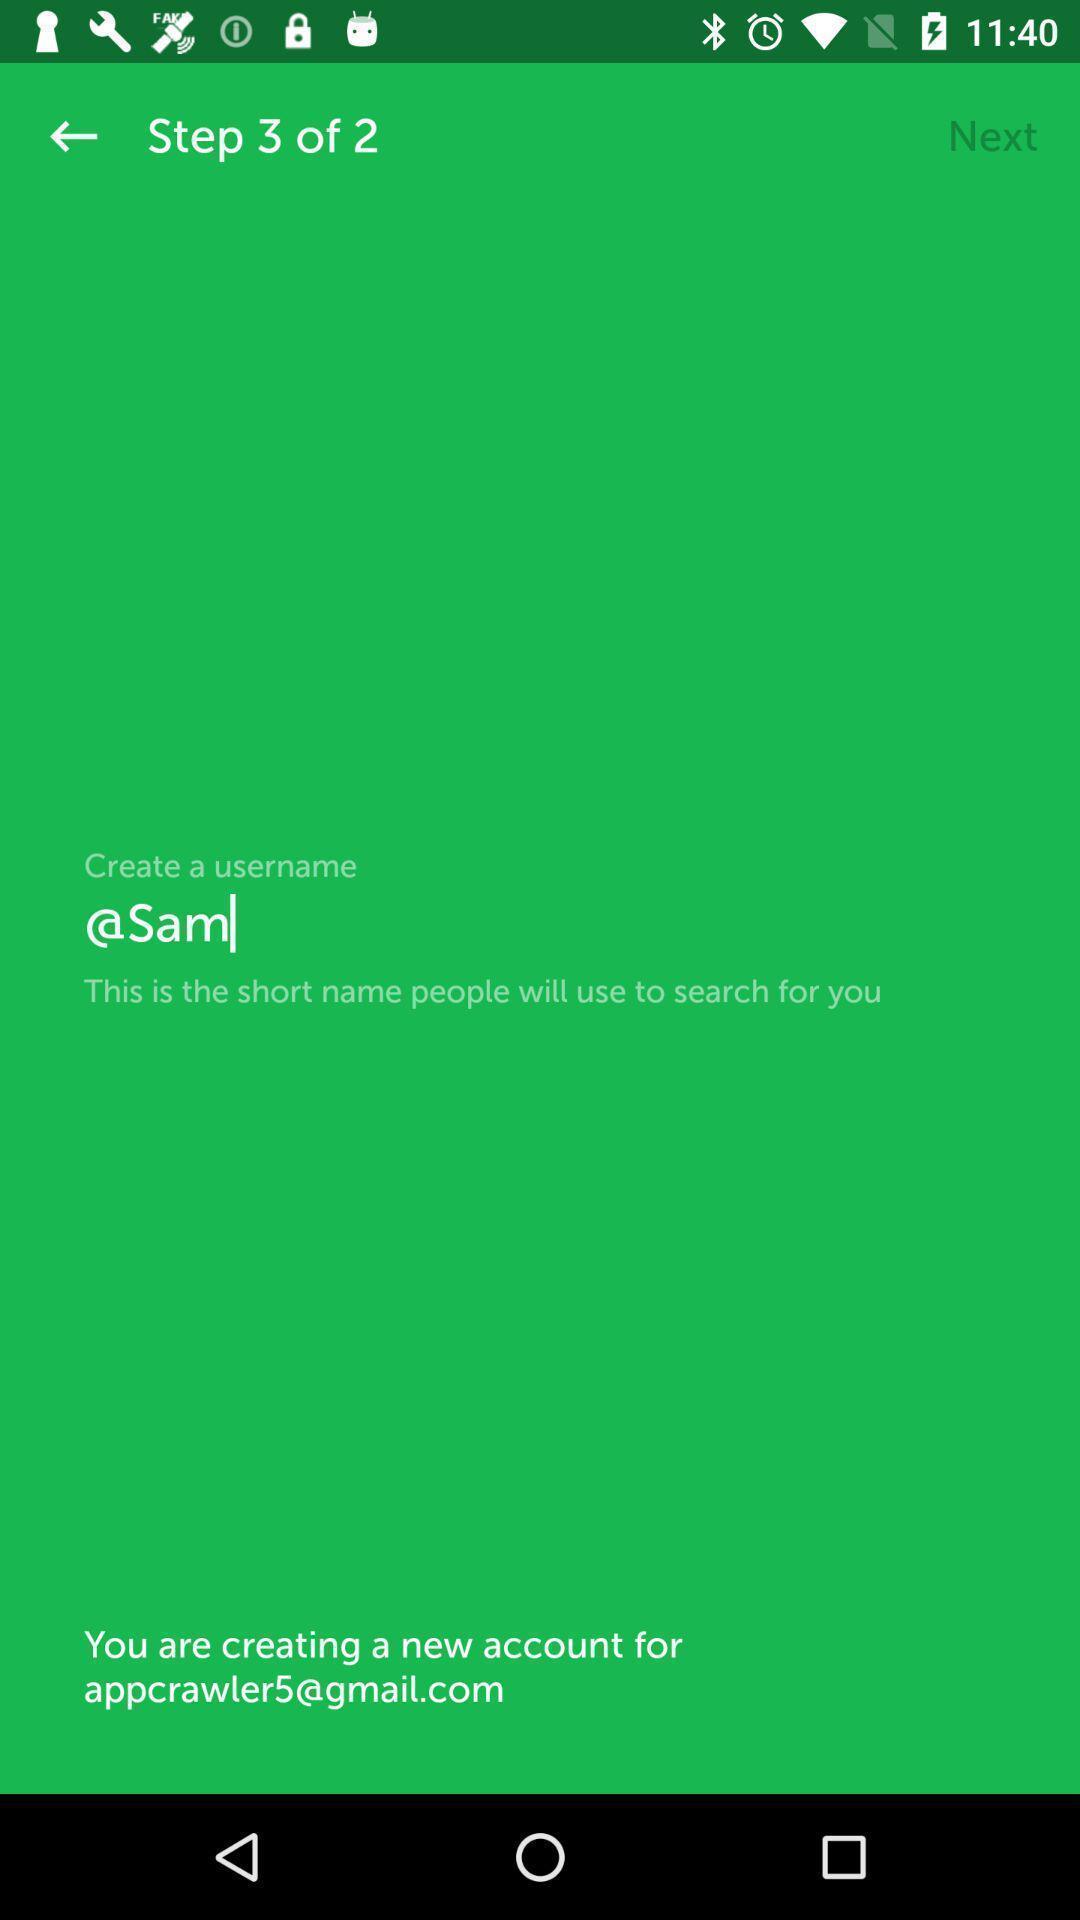Give me a summary of this screen capture. Sign up page for a fishing application. 